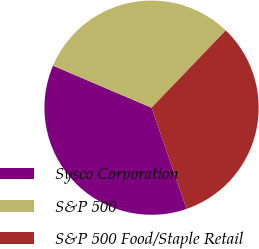<chart> <loc_0><loc_0><loc_500><loc_500><pie_chart><fcel>Sysco Corporation<fcel>S&P 500<fcel>S&P 500 Food/Staple Retail<nl><fcel>36.71%<fcel>30.77%<fcel>32.52%<nl></chart> 